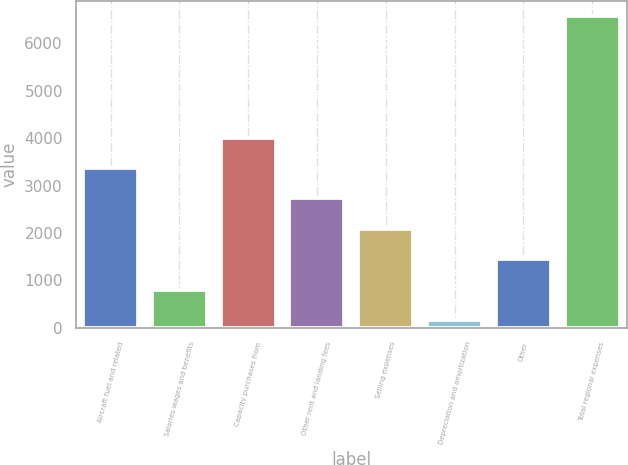Convert chart. <chart><loc_0><loc_0><loc_500><loc_500><bar_chart><fcel>Aircraft fuel and related<fcel>Salaries wages and benefits<fcel>Capacity purchases from<fcel>Other rent and landing fees<fcel>Selling expenses<fcel>Depreciation and amortization<fcel>Other<fcel>Total regional expenses<nl><fcel>3366<fcel>807.6<fcel>4005.6<fcel>2726.4<fcel>2086.8<fcel>168<fcel>1447.2<fcel>6564<nl></chart> 